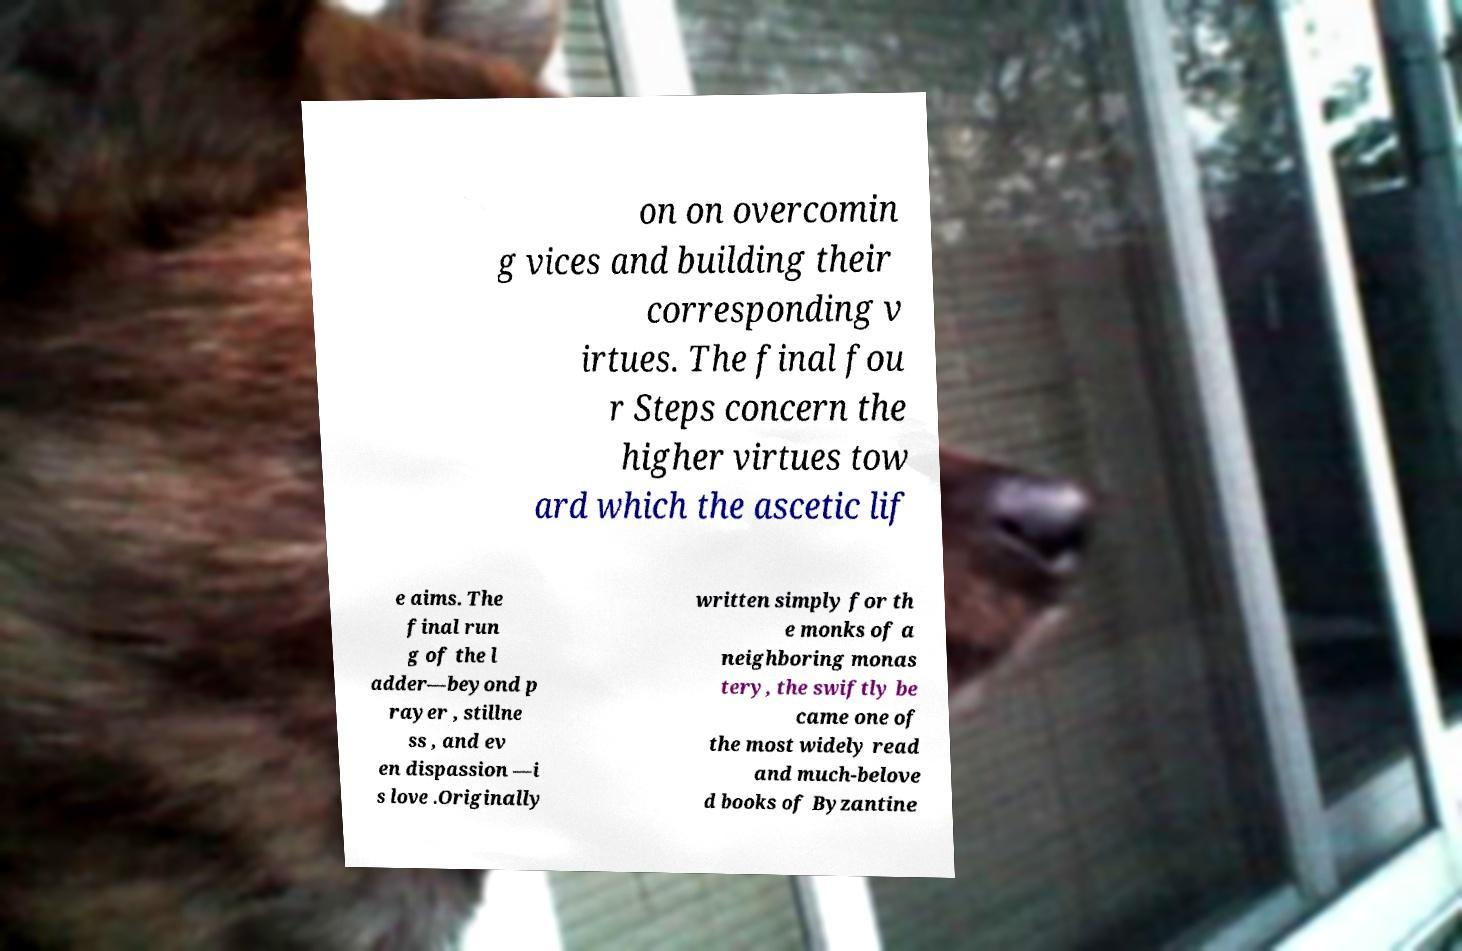Please read and relay the text visible in this image. What does it say? on on overcomin g vices and building their corresponding v irtues. The final fou r Steps concern the higher virtues tow ard which the ascetic lif e aims. The final run g of the l adder—beyond p rayer , stillne ss , and ev en dispassion —i s love .Originally written simply for th e monks of a neighboring monas tery, the swiftly be came one of the most widely read and much-belove d books of Byzantine 